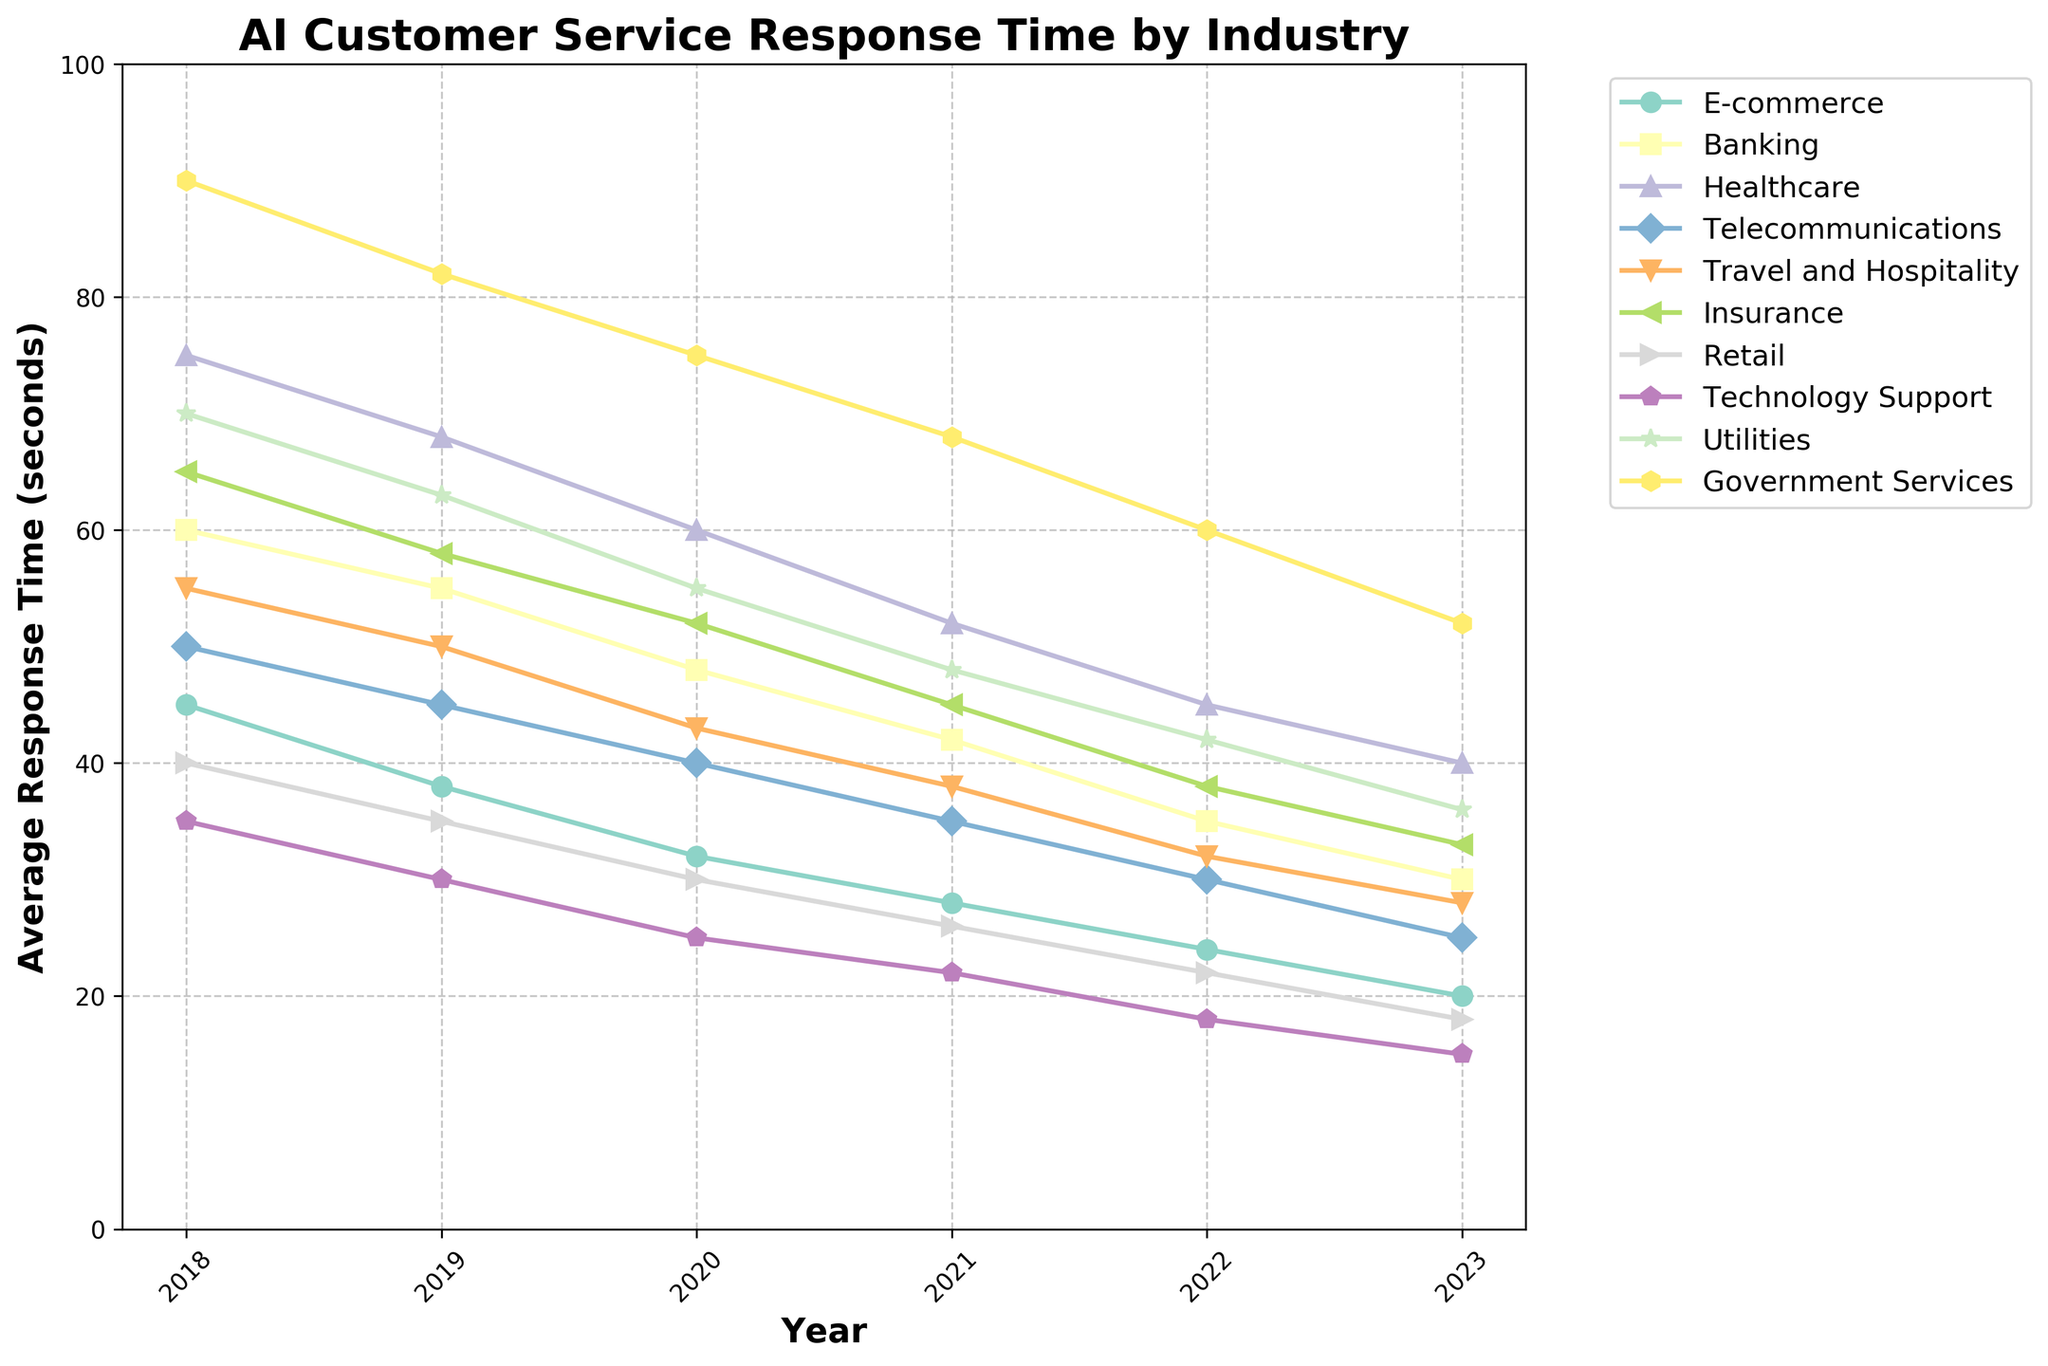What trend do you observe for the average response time of AI customer service systems in the E-commerce industry from 2018 to 2023? The line for E-commerce shows a steady decline from 45 seconds in 2018 to 20 seconds in 2023.
Answer: A steady decline Which industry had the highest average response time in 2023? By observing the final data points, Government Services had the highest average response time at 52 seconds in 2023.
Answer: Government Services How did the average response time for the Banking industry change between 2018 and 2023? The average response time in Banking decreased from 60 seconds in 2018 to 30 seconds in 2023, showing a consistent downward trend.
Answer: Decreased Which two industries had the closest average response times in 2023? The lines representing Insurance and Utilities in 2023 were close together, with average response times of 33 and 36 seconds, respectively.
Answer: Insurance and Utilities What is the difference in average response times between Healthcare and Technology Support in 2023? The average response time for Healthcare in 2023 is 40 seconds and for Technology Support is 15 seconds. The difference is 40 - 15 = 25 seconds.
Answer: 25 seconds Which industry experienced the largest decrease in average response time from 2018 to 2023? Observing the vertical distance between the starting and ending points for each industry, Government Services went from 90 seconds in 2018 to 52 seconds in 2023, a decrease of 38 seconds.
Answer: Government Services In which year did the average response time for the Retail industry become less than 30 seconds? Observing the points on the Retail line, the response time dropped below 30 seconds first in 2020 with a value of 30 seconds.
Answer: 2020 Compare the average response times of Telecommunications and Travel and Hospitality industries in 2021. For 2021, the Telecommunications average response time was 35 seconds and the Travel and Hospitality was 38 seconds. Telecommunications was 3 seconds faster.
Answer: Telecommunications was 3 seconds faster Which industry had a more significant reduction in response time between 2020 and 2023, Banking or Insurance? From 2020 to 2023, Banking reduced from 48 to 30 seconds, a 18-second reduction. Insurance reduced from 52 to 33 seconds, a 19-second reduction.
Answer: Insurance had a more significant reduction What was the average response time of Utilities in 2022 and how does it compare to the average of the other industries in that year? The Utilities response time in 2022 was 42 seconds. To find the average for other industries, sum their 2022 values (excluding Utilities) and divide by 9. So, the average is [(24+35+45+30+32+38+22+18+60)/9] which is 33.78 seconds. Thus, Utilities' response time is higher.
Answer: 42 seconds; higher than the average 